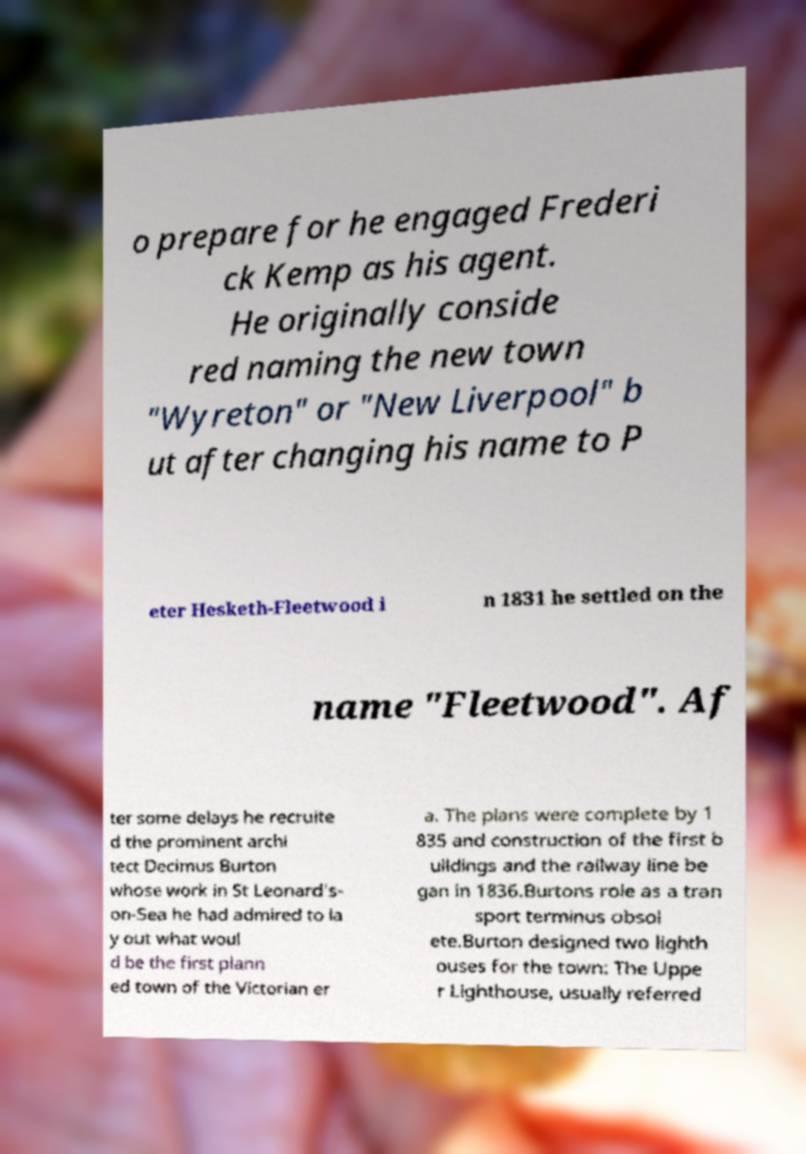Can you read and provide the text displayed in the image?This photo seems to have some interesting text. Can you extract and type it out for me? o prepare for he engaged Frederi ck Kemp as his agent. He originally conside red naming the new town "Wyreton" or "New Liverpool" b ut after changing his name to P eter Hesketh-Fleetwood i n 1831 he settled on the name "Fleetwood". Af ter some delays he recruite d the prominent archi tect Decimus Burton whose work in St Leonard's- on-Sea he had admired to la y out what woul d be the first plann ed town of the Victorian er a. The plans were complete by 1 835 and construction of the first b uildings and the railway line be gan in 1836.Burtons role as a tran sport terminus obsol ete.Burton designed two lighth ouses for the town: The Uppe r Lighthouse, usually referred 